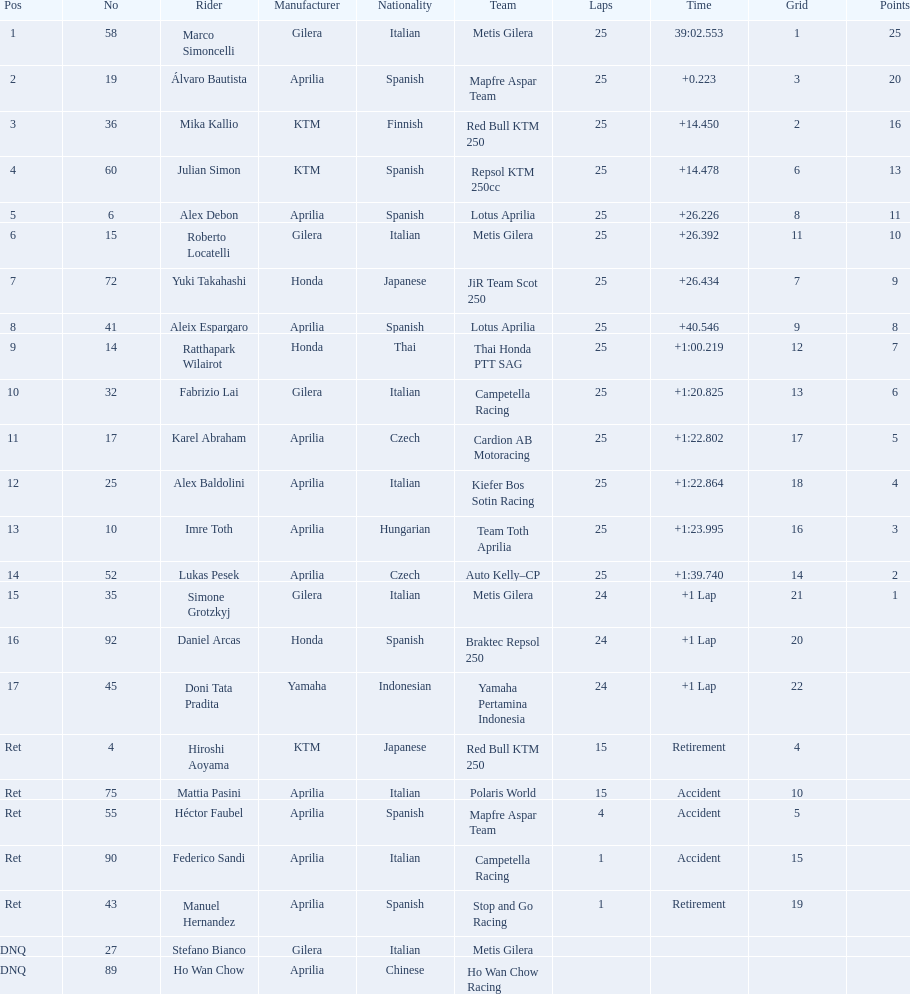How many laps did marco perform? 25. How many laps did hiroshi perform? 15. Which of these numbers are higher? 25. Who swam this number of laps? Marco Simoncelli. 